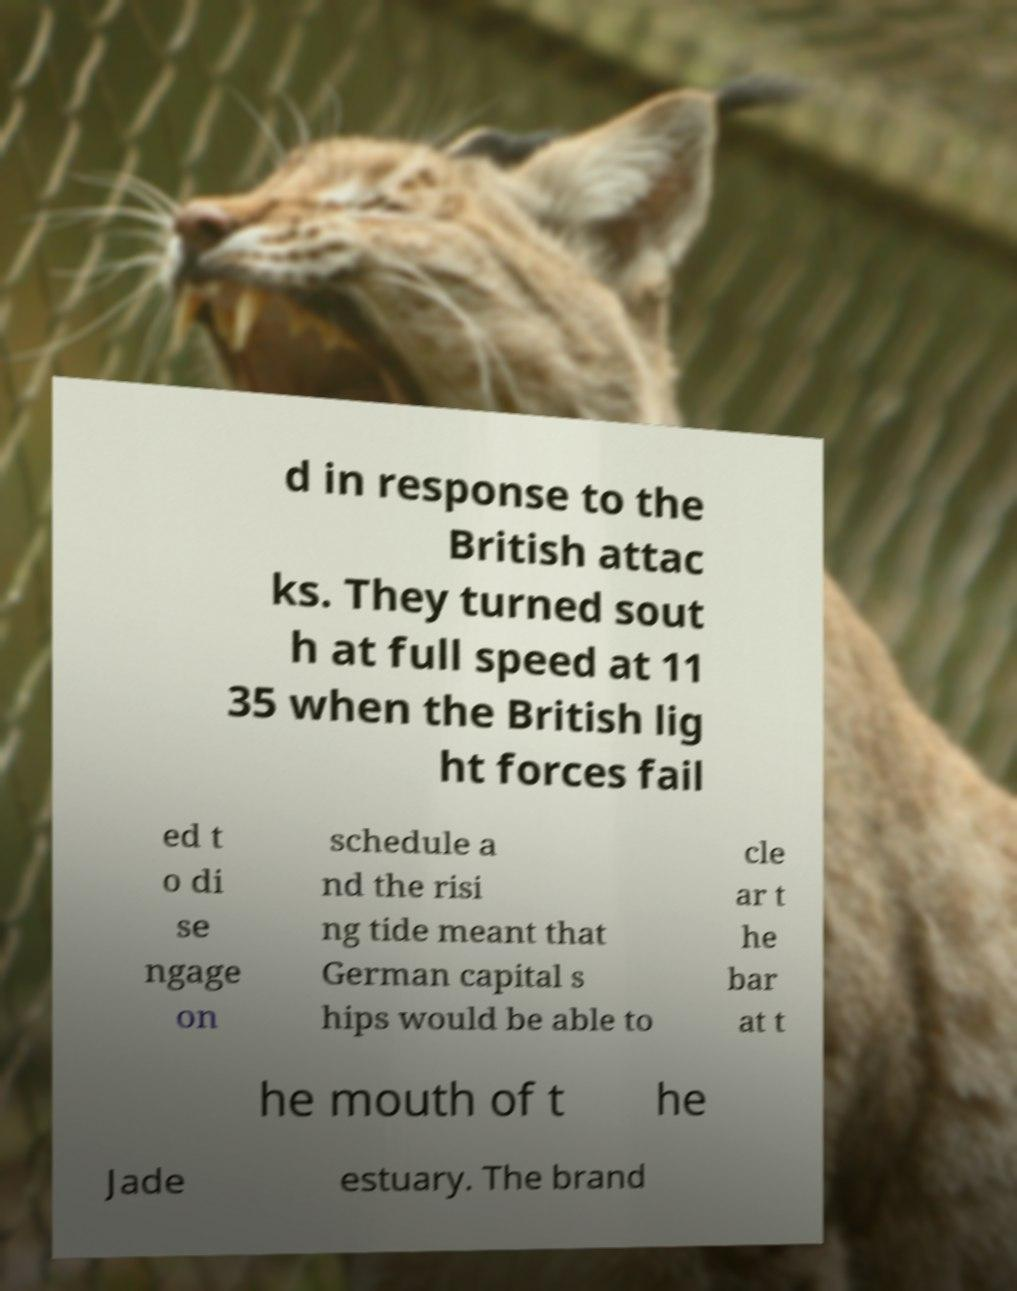Please read and relay the text visible in this image. What does it say? d in response to the British attac ks. They turned sout h at full speed at 11 35 when the British lig ht forces fail ed t o di se ngage on schedule a nd the risi ng tide meant that German capital s hips would be able to cle ar t he bar at t he mouth of t he Jade estuary. The brand 